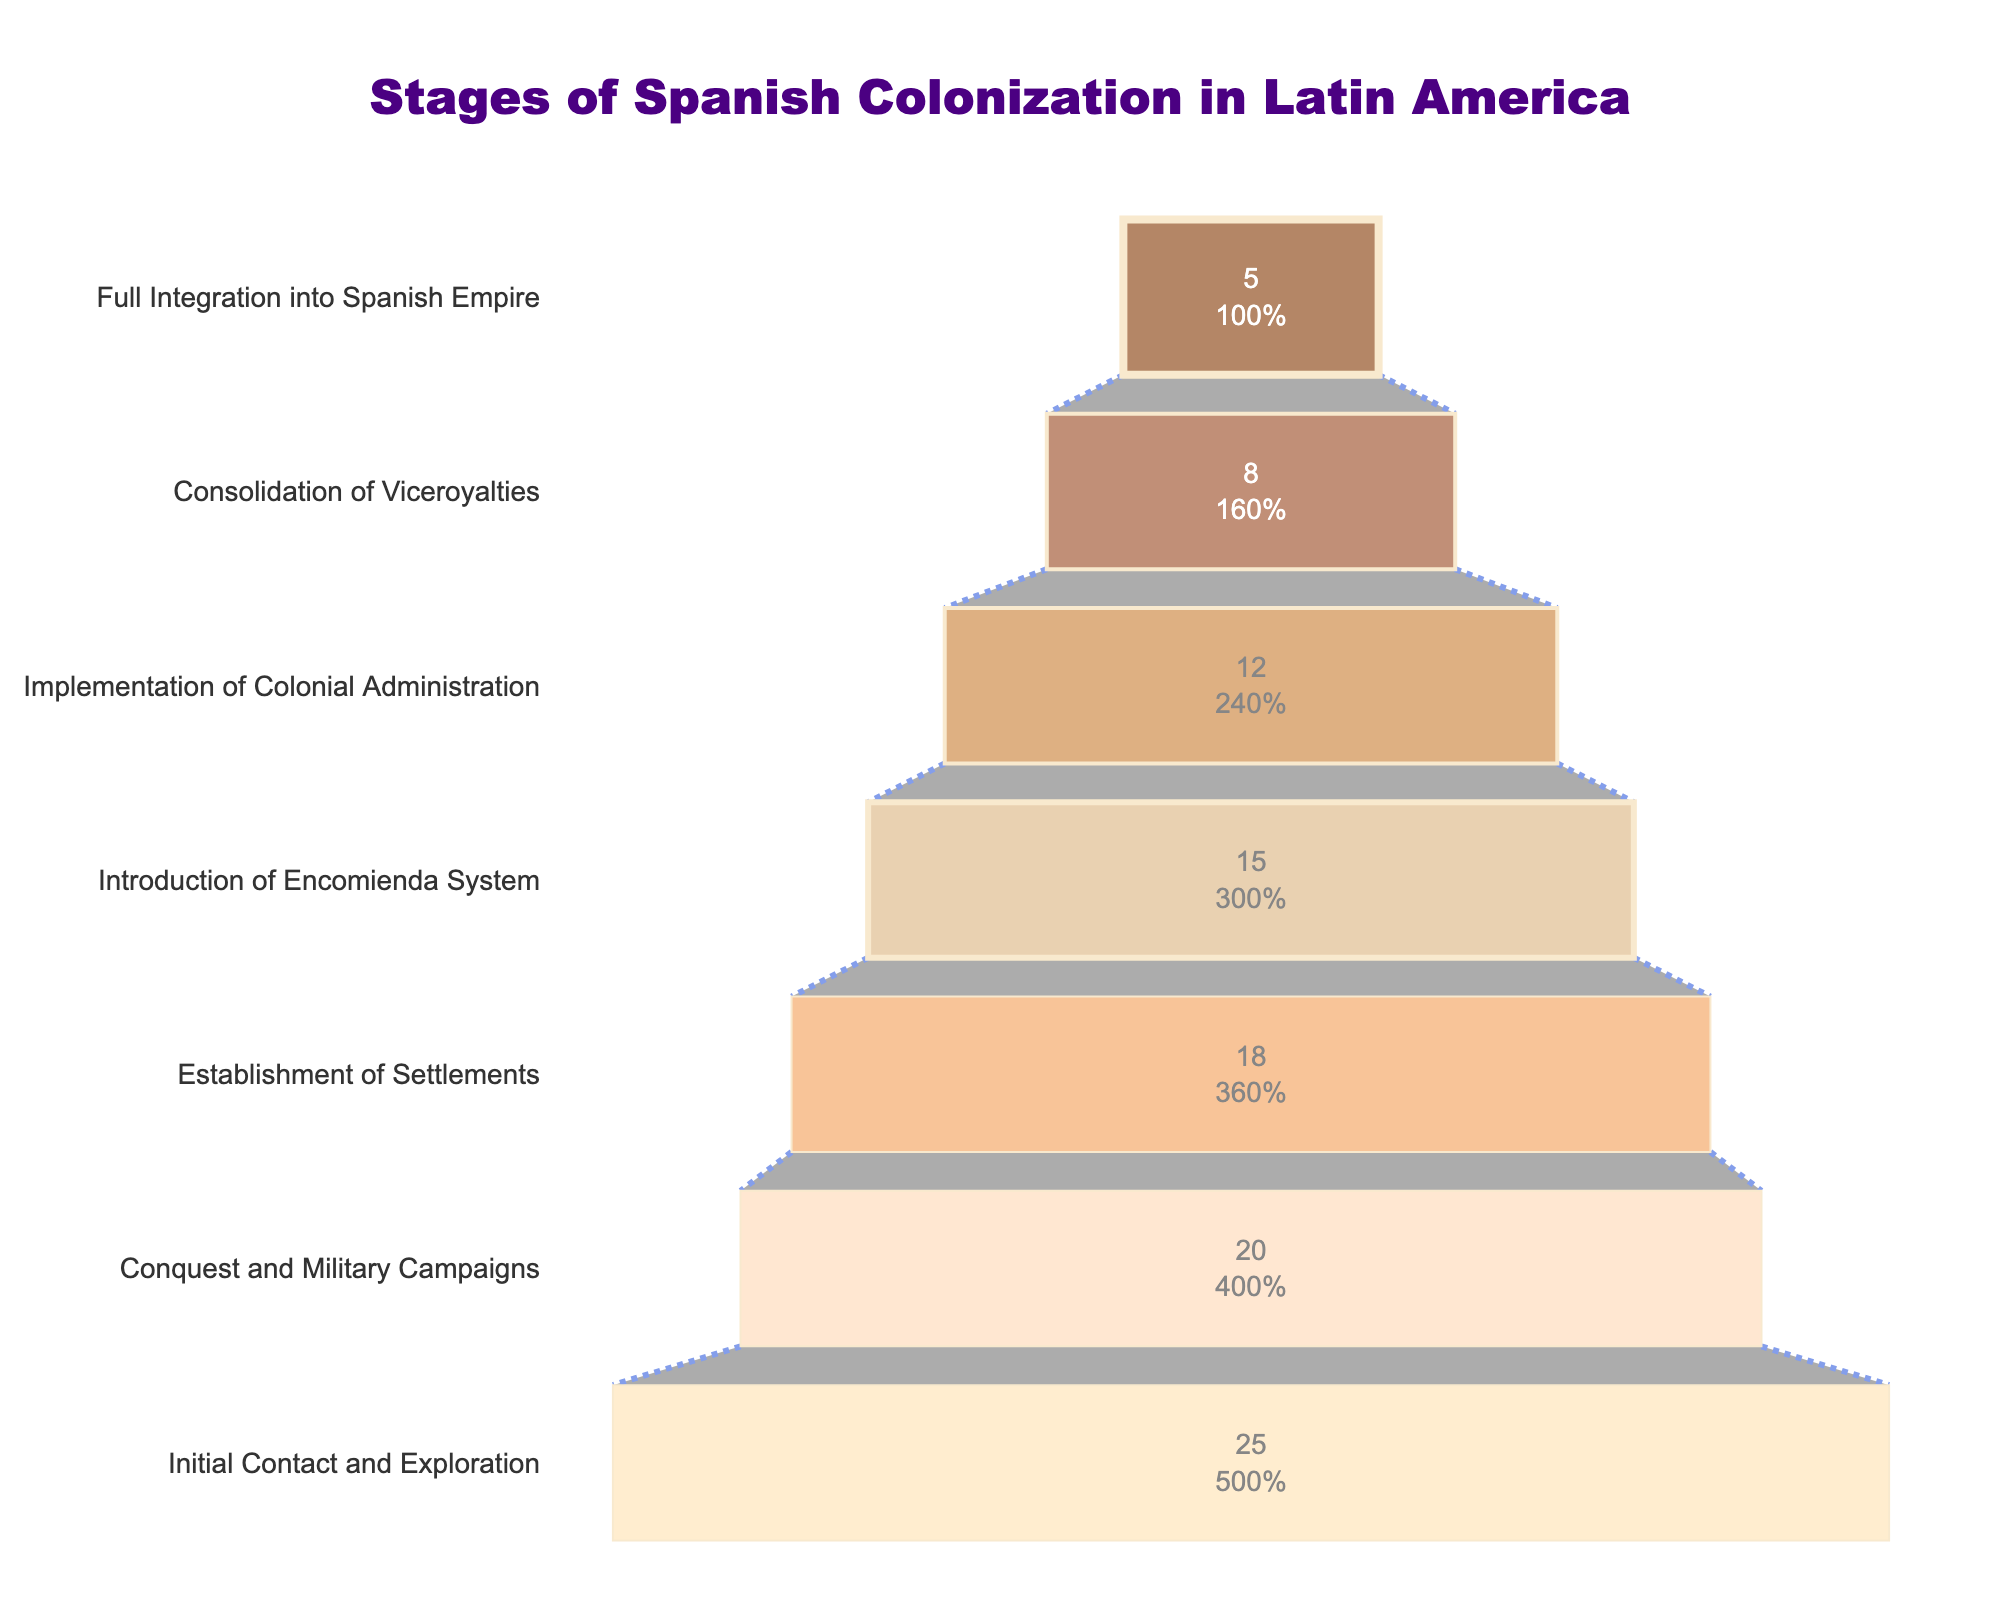What is the title of the funnel chart? Look at the top center of the funnel chart where the title is usually located. The text 'Stages of Spanish Colonization in Latin America' clearly indicates the title.
Answer: Stages of Spanish Colonization in Latin America Which stage had the highest number of territories? The highest stage is at the widest part of the funnel. 'Initial Contact and Exploration' stage is the widest and has 25 territories.
Answer: Initial Contact and Exploration How many stages are depicted in the chart? Count the number of different horizontal segments in the funnel, each representing a stage. They are 7 in total.
Answer: 7 What is the percentage of territories at the 'Consolidation of Viceroyalties' stage relative to the initial stage? Calculate the percentage by dividing the number of territories at 'Consolidation of Viceroyalties' by the number at 'Initial Contact and Exploration', then multiply by 100: (8 / 25) * 100.
Answer: 32% Which stages have more than 15 territories? Identify each horizontal segment and its corresponding number. The stages with more than 15 territories are: 'Initial Contact and Exploration' (25), 'Conquest and Military Campaigns' (20), and 'Establishment of Settlements' (18).
Answer: Initial Contact and Exploration, Conquest and Military Campaigns, Establishment of Settlements What's the difference in the number of territories between 'Introduction of Encomienda System' and 'Implementation of Colonial Administration' stages? Subtract the number of territories in the 'Implementation of Colonial Administration' stage from the 'Introduction of Encomienda System': 15 - 12.
Answer: 3 Which stage has the least number of territories, and what is that number? The narrowest segment at the bottom of the funnel represents the stage with the least territories, which is 'Full Integration into Spanish Empire' with 5 territories.
Answer: Full Integration into Spanish Empire, 5 How many territories were involved in the stages after the 'Initial Contact and Exploration' stage in total? Sum the number of territories from all stages after 'Initial Contact and Exploration': 20 + 18 + 15 + 12 + 8 + 5.
Answer: 78 Compare the number of territories in 'Conquest and Military Campaigns' with 'Consolidation of Viceroyalties'. Which has a higher number and by how much? Identify the numbers for both stages and subtract the smaller from the larger: 20 (Conquest and Military Campaigns) - 8 (Consolidation of Viceroyalties).
Answer: Conquest and Military Campaigns; by 12 What is the average number of territories across all stages? Sum all the territories and divide by the number of stages: (25 + 20 + 18 + 15 + 12 + 8 + 5) / 7.
Answer: 14.71 